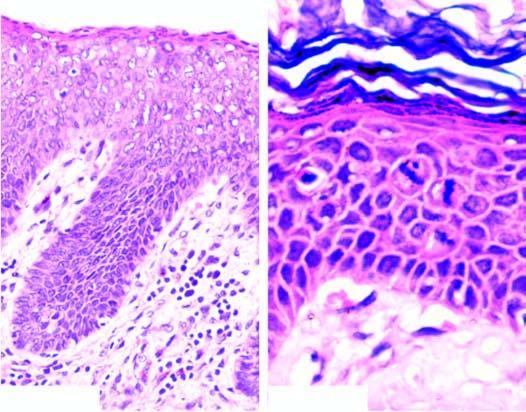does photomicrograph on right under higher magnification show mitotic figures in the layers of squamous epithelium?
Answer the question using a single word or phrase. Yes 